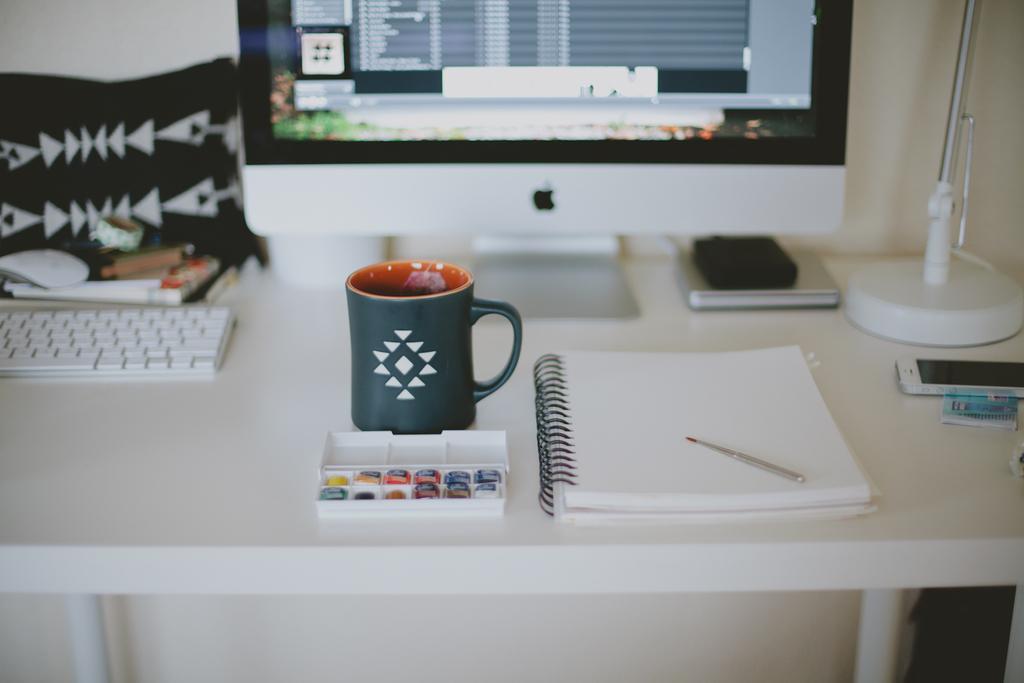Could you give a brief overview of what you see in this image? In this image there is a table. On top of it there is a cup, book, pen and a box. A monitor is in middle of image. Right corner there is a mobile and stand. At left side there is a keyboard and cushion. 